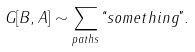Convert formula to latex. <formula><loc_0><loc_0><loc_500><loc_500>G [ B , A ] \sim \sum _ { p a t h s } \lq \lq s o m e t h i n g " .</formula> 